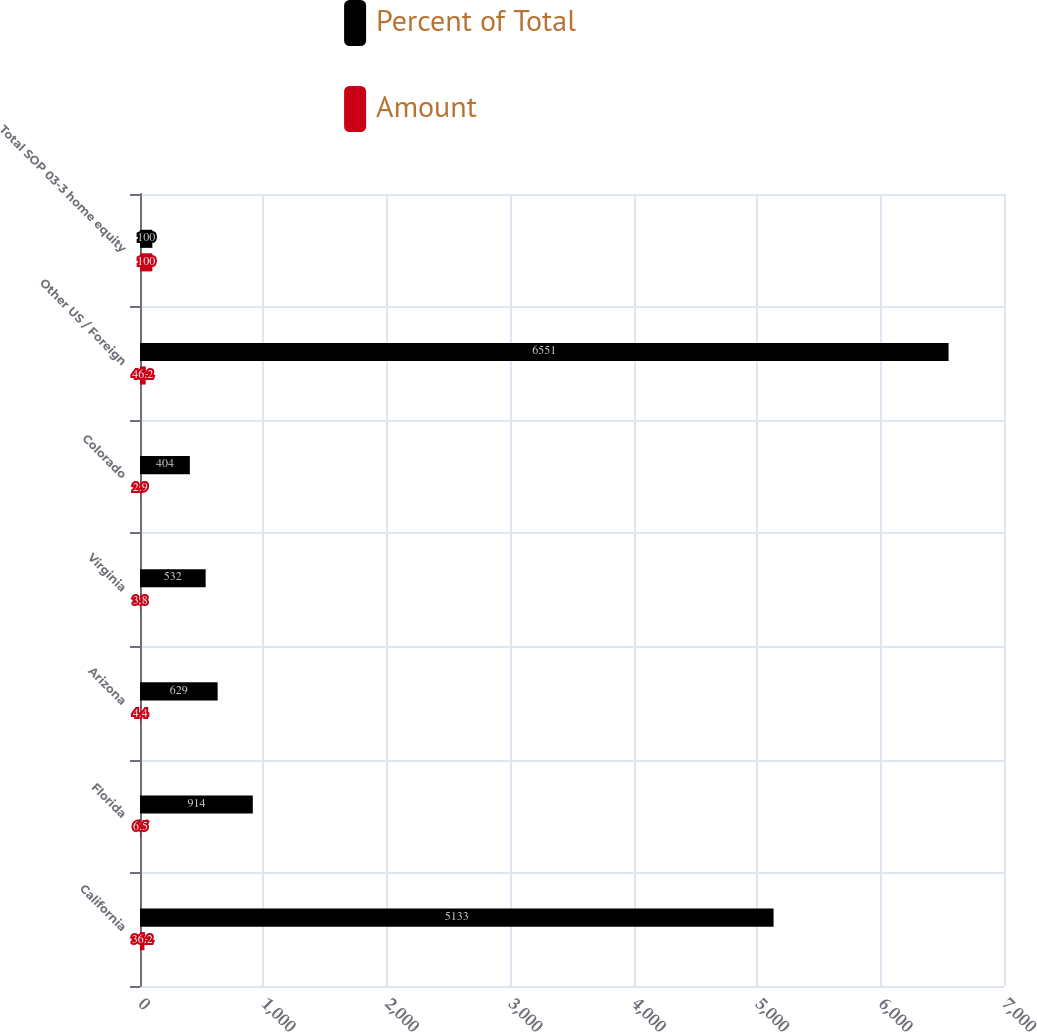Convert chart to OTSL. <chart><loc_0><loc_0><loc_500><loc_500><stacked_bar_chart><ecel><fcel>California<fcel>Florida<fcel>Arizona<fcel>Virginia<fcel>Colorado<fcel>Other US / Foreign<fcel>Total SOP 03-3 home equity<nl><fcel>Percent of Total<fcel>5133<fcel>914<fcel>629<fcel>532<fcel>404<fcel>6551<fcel>100<nl><fcel>Amount<fcel>36.2<fcel>6.5<fcel>4.4<fcel>3.8<fcel>2.9<fcel>46.2<fcel>100<nl></chart> 